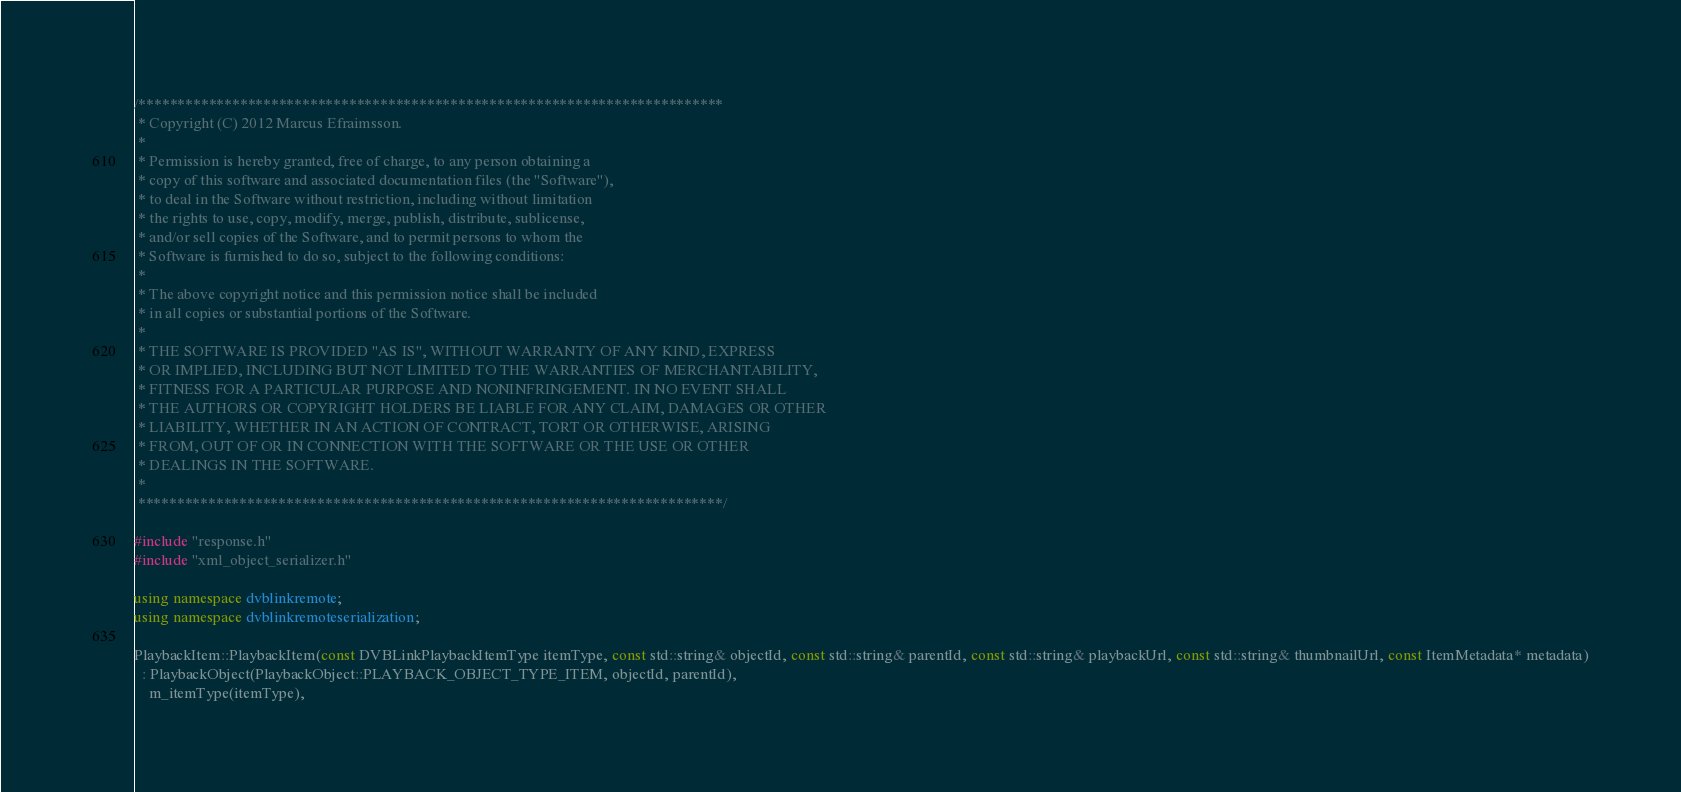Convert code to text. <code><loc_0><loc_0><loc_500><loc_500><_C++_>/***************************************************************************
 * Copyright (C) 2012 Marcus Efraimsson.
 *
 * Permission is hereby granted, free of charge, to any person obtaining a 
 * copy of this software and associated documentation files (the "Software"), 
 * to deal in the Software without restriction, including without limitation 
 * the rights to use, copy, modify, merge, publish, distribute, sublicense, 
 * and/or sell copies of the Software, and to permit persons to whom the 
 * Software is furnished to do so, subject to the following conditions:
 *
 * The above copyright notice and this permission notice shall be included 
 * in all copies or substantial portions of the Software.
 *
 * THE SOFTWARE IS PROVIDED "AS IS", WITHOUT WARRANTY OF ANY KIND, EXPRESS 
 * OR IMPLIED, INCLUDING BUT NOT LIMITED TO THE WARRANTIES OF MERCHANTABILITY, 
 * FITNESS FOR A PARTICULAR PURPOSE AND NONINFRINGEMENT. IN NO EVENT SHALL 
 * THE AUTHORS OR COPYRIGHT HOLDERS BE LIABLE FOR ANY CLAIM, DAMAGES OR OTHER 
 * LIABILITY, WHETHER IN AN ACTION OF CONTRACT, TORT OR OTHERWISE, ARISING 
 * FROM, OUT OF OR IN CONNECTION WITH THE SOFTWARE OR THE USE OR OTHER 
 * DEALINGS IN THE SOFTWARE.
 *
 ***************************************************************************/

#include "response.h"
#include "xml_object_serializer.h"

using namespace dvblinkremote;
using namespace dvblinkremoteserialization;

PlaybackItem::PlaybackItem(const DVBLinkPlaybackItemType itemType, const std::string& objectId, const std::string& parentId, const std::string& playbackUrl, const std::string& thumbnailUrl, const ItemMetadata* metadata)
  : PlaybackObject(PlaybackObject::PLAYBACK_OBJECT_TYPE_ITEM, objectId, parentId),
    m_itemType(itemType),</code> 